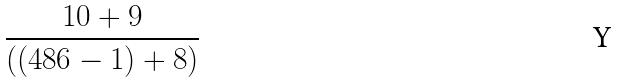Convert formula to latex. <formula><loc_0><loc_0><loc_500><loc_500>\frac { 1 0 + 9 } { ( ( 4 8 6 - 1 ) + 8 ) }</formula> 